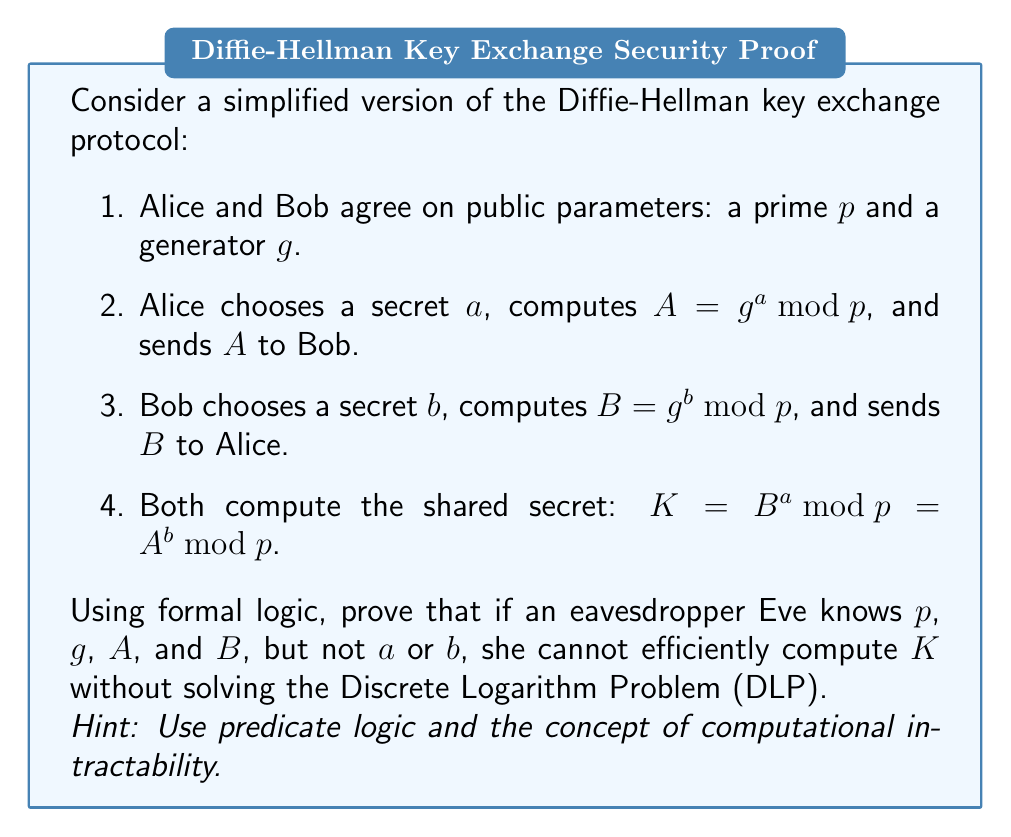Can you answer this question? Let's approach this proof step-by-step using formal logic:

1. Define predicates:
   $\text{Knows}(x, y)$: Agent $x$ knows value $y$
   $\text{Computes}(x, y)$: Agent $x$ can efficiently compute $y$
   $\text{DLP}(x)$: Agent $x$ can solve the Discrete Logarithm Problem

2. Given information:
   $\text{Knows}(\text{Eve}, p) \wedge \text{Knows}(\text{Eve}, g) \wedge \text{Knows}(\text{Eve}, A) \wedge \text{Knows}(\text{Eve}, B)$
   $\neg \text{Knows}(\text{Eve}, a) \wedge \neg \text{Knows}(\text{Eve}, b)$

3. Definition of $K$:
   $K = B^a \mod p = A^b \mod p = g^{ab} \mod p$

4. Assumption about DLP:
   $\forall x, \neg \text{DLP}(x) \rightarrow \neg \text{Computes}(x, a) \wedge \neg \text{Computes}(x, b)$

5. Logical implication:
   $\text{Computes}(\text{Eve}, K) \rightarrow \text{Computes}(\text{Eve}, g^{ab} \mod p)$

6. By contraposition of step 4:
   $\text{Computes}(\text{Eve}, a) \vee \text{Computes}(\text{Eve}, b) \rightarrow \text{DLP}(\text{Eve})$

7. From steps 5 and 6:
   $\text{Computes}(\text{Eve}, K) \rightarrow \text{DLP}(\text{Eve})$

8. Conclusion:
   $\neg \text{DLP}(\text{Eve}) \rightarrow \neg \text{Computes}(\text{Eve}, K)$

This formal logic proof demonstrates that if Eve cannot solve the Discrete Logarithm Problem, she cannot efficiently compute the shared secret $K$, thus proving the correctness of the simplified Diffie-Hellman protocol under the assumption of DLP's computational intractability.
Answer: $\neg \text{DLP}(\text{Eve}) \rightarrow \neg \text{Computes}(\text{Eve}, K)$ 